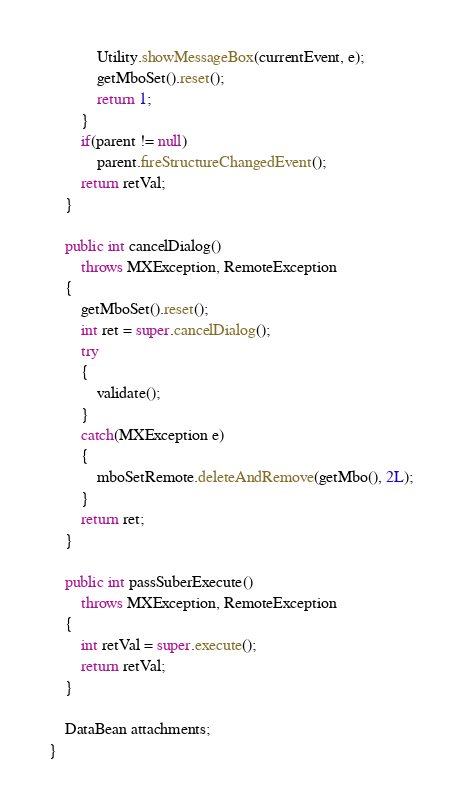<code> <loc_0><loc_0><loc_500><loc_500><_Java_>            Utility.showMessageBox(currentEvent, e);
            getMboSet().reset();
            return 1;
        }
        if(parent != null)
            parent.fireStructureChangedEvent();
        return retVal;
    }

    public int cancelDialog()
        throws MXException, RemoteException
    {
        getMboSet().reset();
        int ret = super.cancelDialog();
        try
        {
            validate();
        }
        catch(MXException e)
        {
            mboSetRemote.deleteAndRemove(getMbo(), 2L);
        }
        return ret;
    }

    public int passSuberExecute()
        throws MXException, RemoteException
    {
        int retVal = super.execute();
        return retVal;
    }

    DataBean attachments;
}
</code> 